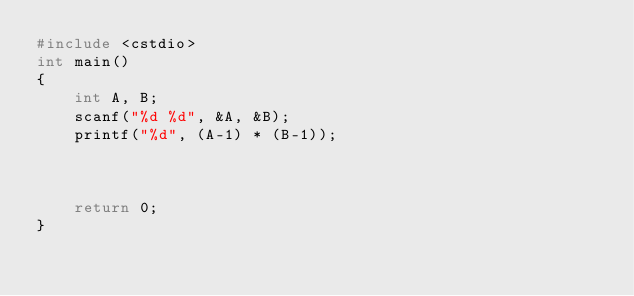<code> <loc_0><loc_0><loc_500><loc_500><_C++_>#include <cstdio>
int main()
{
    int A, B;
    scanf("%d %d", &A, &B);
    printf("%d", (A-1) * (B-1));
    
    
        
    return 0;
}

</code> 